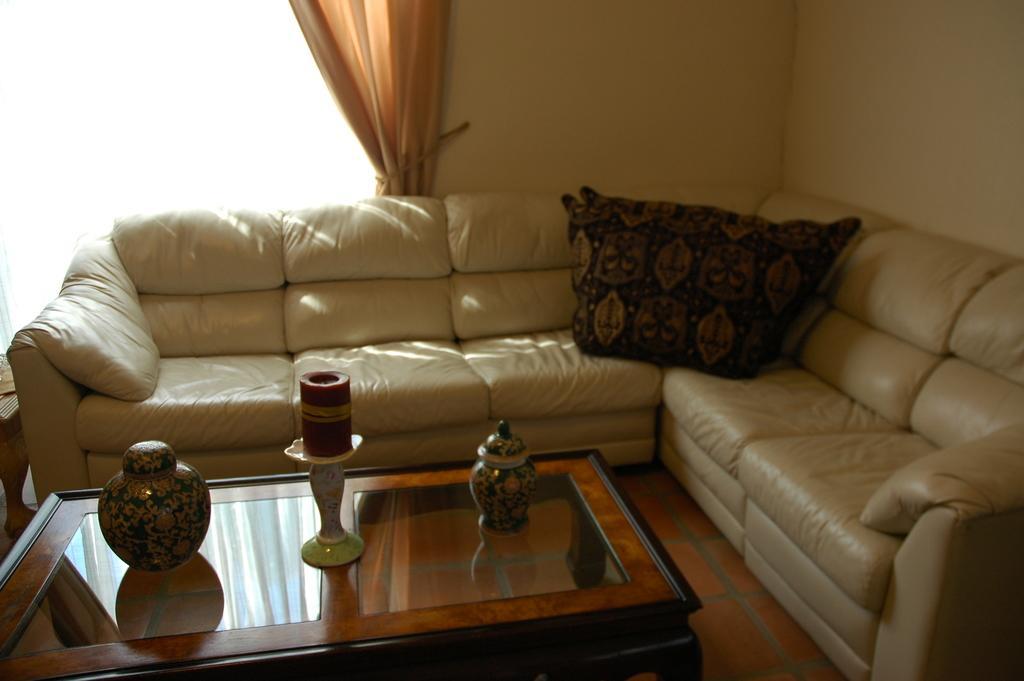Please provide a concise description of this image. In a living room there is cream color sofa,with dark color pillows on it. There is table beside with few items on it. There is a glass window with curtain beside it. 